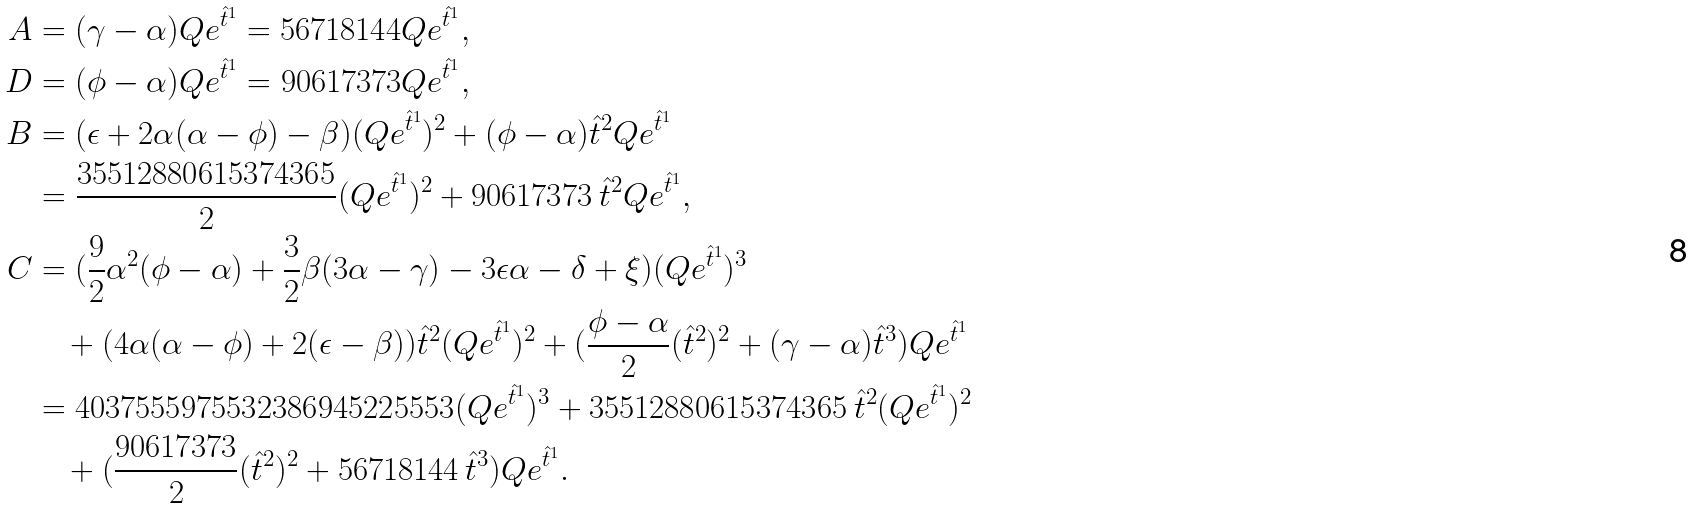<formula> <loc_0><loc_0><loc_500><loc_500>A & = ( \gamma - \alpha ) Q e ^ { \hat { t } ^ { 1 } } = 5 6 7 1 8 1 4 4 Q e ^ { \hat { t } ^ { 1 } } , \\ D & = ( \phi - \alpha ) Q e ^ { \hat { t } ^ { 1 } } = 9 0 6 1 7 3 7 3 Q e ^ { \hat { t } ^ { 1 } } , \\ B & = ( \epsilon + 2 \alpha ( \alpha - \phi ) - \beta ) ( Q e ^ { \hat { t } ^ { 1 } } ) ^ { 2 } + ( \phi - \alpha ) \hat { t } ^ { 2 } Q e ^ { \hat { t } ^ { 1 } } \\ & = \frac { 3 5 5 1 2 8 8 0 6 1 5 3 7 4 3 6 5 } { 2 } ( Q e ^ { \hat { t } ^ { 1 } } ) ^ { 2 } + 9 0 6 1 7 3 7 3 \, \hat { t } ^ { 2 } Q e ^ { \hat { t } ^ { 1 } } , \\ C & = ( \frac { 9 } { 2 } \alpha ^ { 2 } ( \phi - \alpha ) + \frac { 3 } { 2 } \beta ( 3 \alpha - \gamma ) - 3 \epsilon \alpha - \delta + \xi ) ( Q e ^ { \hat { t } ^ { 1 } } ) ^ { 3 } \\ & \quad + ( 4 \alpha ( \alpha - \phi ) + 2 ( \epsilon - \beta ) ) \hat { t } ^ { 2 } ( Q e ^ { \hat { t } ^ { 1 } } ) ^ { 2 } + ( \frac { \phi - \alpha } { 2 } ( \hat { t } ^ { 2 } ) ^ { 2 } + ( \gamma - \alpha ) { \hat { t } ^ { 3 } } ) Q e ^ { \hat { t } ^ { 1 } } \\ & = 4 0 3 7 5 5 5 9 7 5 5 3 2 3 8 6 9 4 5 2 2 5 5 5 3 ( Q e ^ { \hat { t } ^ { 1 } } ) ^ { 3 } + 3 5 5 1 2 8 8 0 6 1 5 3 7 4 3 6 5 \, \hat { t } ^ { 2 } ( Q e ^ { \hat { t } ^ { 1 } } ) ^ { 2 } \\ & \quad + ( \frac { 9 0 6 1 7 3 7 3 } { 2 } ( \hat { t } ^ { 2 } ) ^ { 2 } + 5 6 7 1 8 1 4 4 \, \hat { t } ^ { 3 } ) Q e ^ { \hat { t } ^ { 1 } } .</formula> 